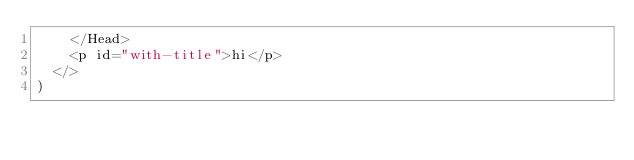Convert code to text. <code><loc_0><loc_0><loc_500><loc_500><_JavaScript_>    </Head>
    <p id="with-title">hi</p>
  </>
)
</code> 